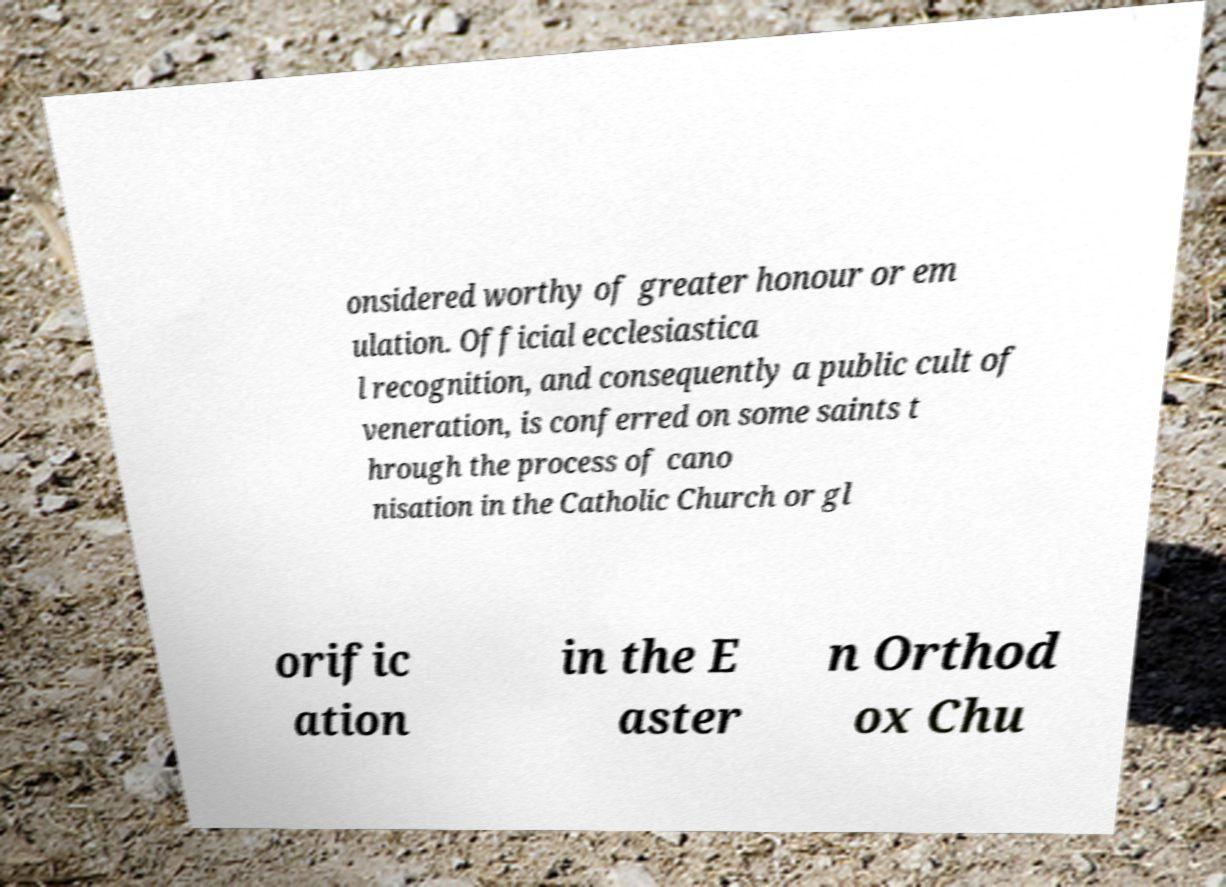What messages or text are displayed in this image? I need them in a readable, typed format. onsidered worthy of greater honour or em ulation. Official ecclesiastica l recognition, and consequently a public cult of veneration, is conferred on some saints t hrough the process of cano nisation in the Catholic Church or gl orific ation in the E aster n Orthod ox Chu 